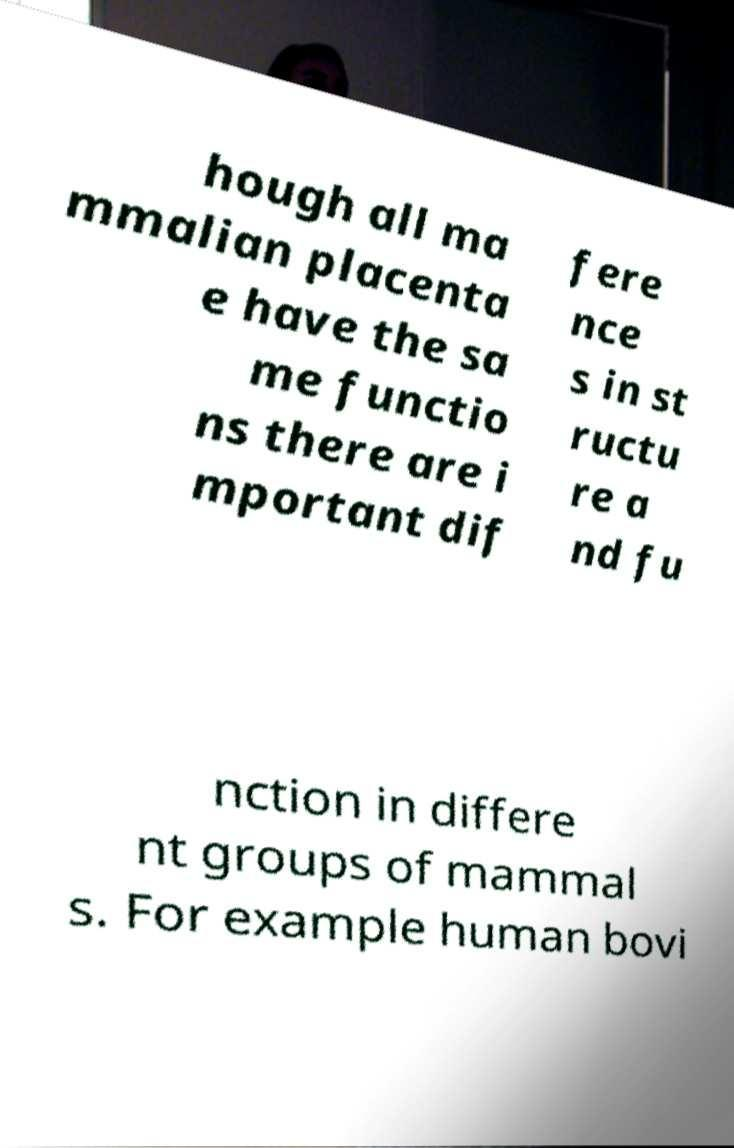Can you accurately transcribe the text from the provided image for me? hough all ma mmalian placenta e have the sa me functio ns there are i mportant dif fere nce s in st ructu re a nd fu nction in differe nt groups of mammal s. For example human bovi 